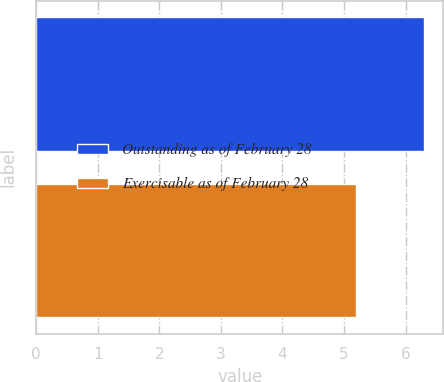<chart> <loc_0><loc_0><loc_500><loc_500><bar_chart><fcel>Outstanding as of February 28<fcel>Exercisable as of February 28<nl><fcel>6.3<fcel>5.2<nl></chart> 